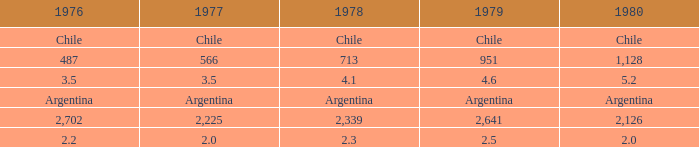What does 1980 represent when 1979 is 951? 1128.0. 